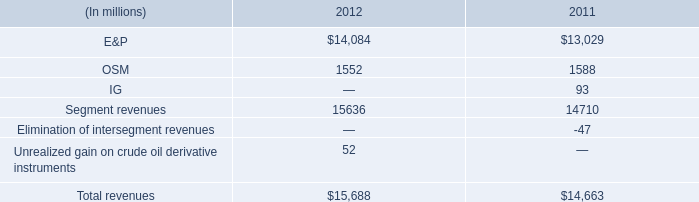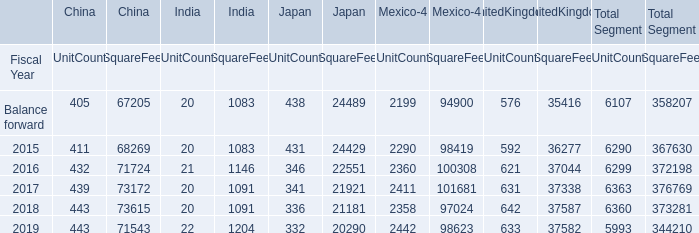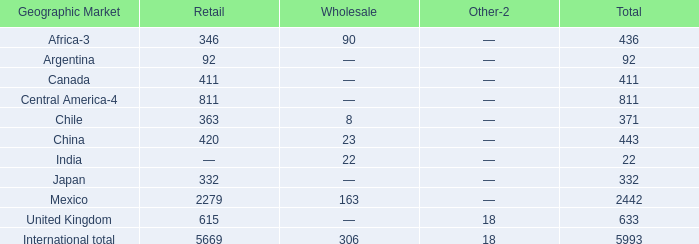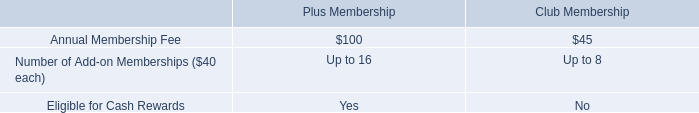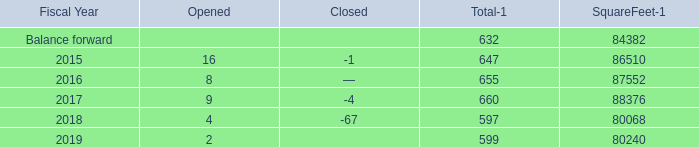what's the total amount of Balance forward of SquareFeet, and 2018 of Mexico UnitCount ? 
Computations: (84382.0 + 2358.0)
Answer: 86740.0. 